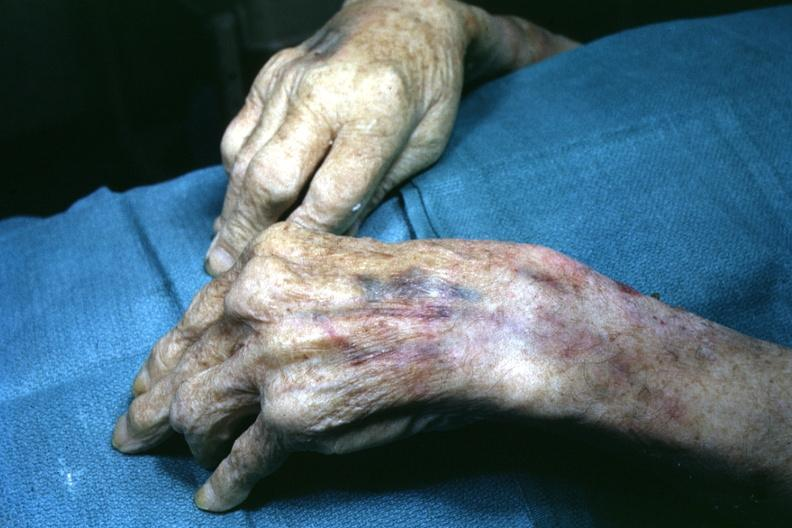what are present?
Answer the question using a single word or phrase. Extremities 